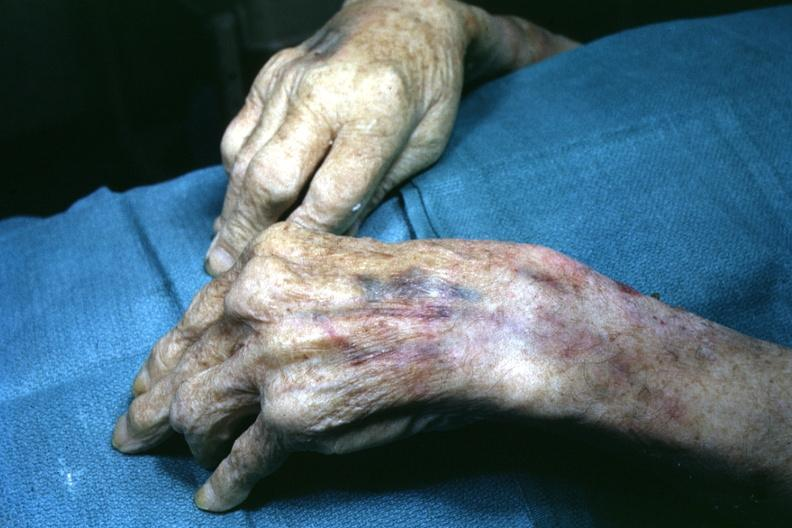what are present?
Answer the question using a single word or phrase. Extremities 